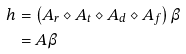Convert formula to latex. <formula><loc_0><loc_0><loc_500><loc_500>h & = \left ( A _ { r } \diamond A _ { t } \diamond A _ { d } \diamond A _ { f } \right ) \beta \\ & = A \beta</formula> 